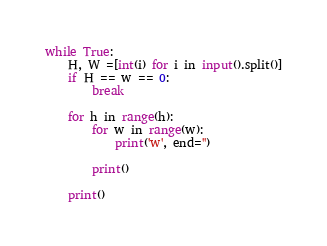Convert code to text. <code><loc_0><loc_0><loc_500><loc_500><_Python_>while True:
    H, W =[int(i) for i in input().split()]
    if H == w == 0:
        break

    for h in range(h):
        for w in range(w):
            print('w', end='')
        
        print()

    print()</code> 